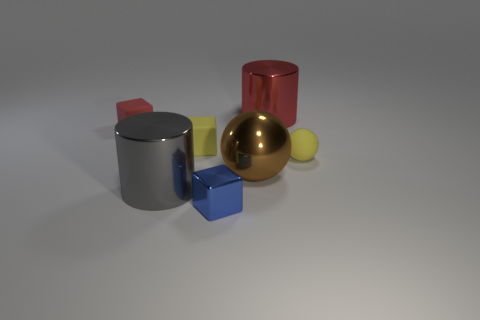Add 1 red rubber cubes. How many objects exist? 8 Subtract all small matte cubes. How many cubes are left? 1 Subtract 1 spheres. How many spheres are left? 1 Subtract all red cylinders. How many cylinders are left? 1 Subtract all cylinders. How many objects are left? 5 Subtract all brown cubes. How many gray balls are left? 0 Add 4 metallic things. How many metallic things are left? 8 Add 7 large gray shiny blocks. How many large gray shiny blocks exist? 7 Subtract 1 blue cubes. How many objects are left? 6 Subtract all green cylinders. Subtract all brown balls. How many cylinders are left? 2 